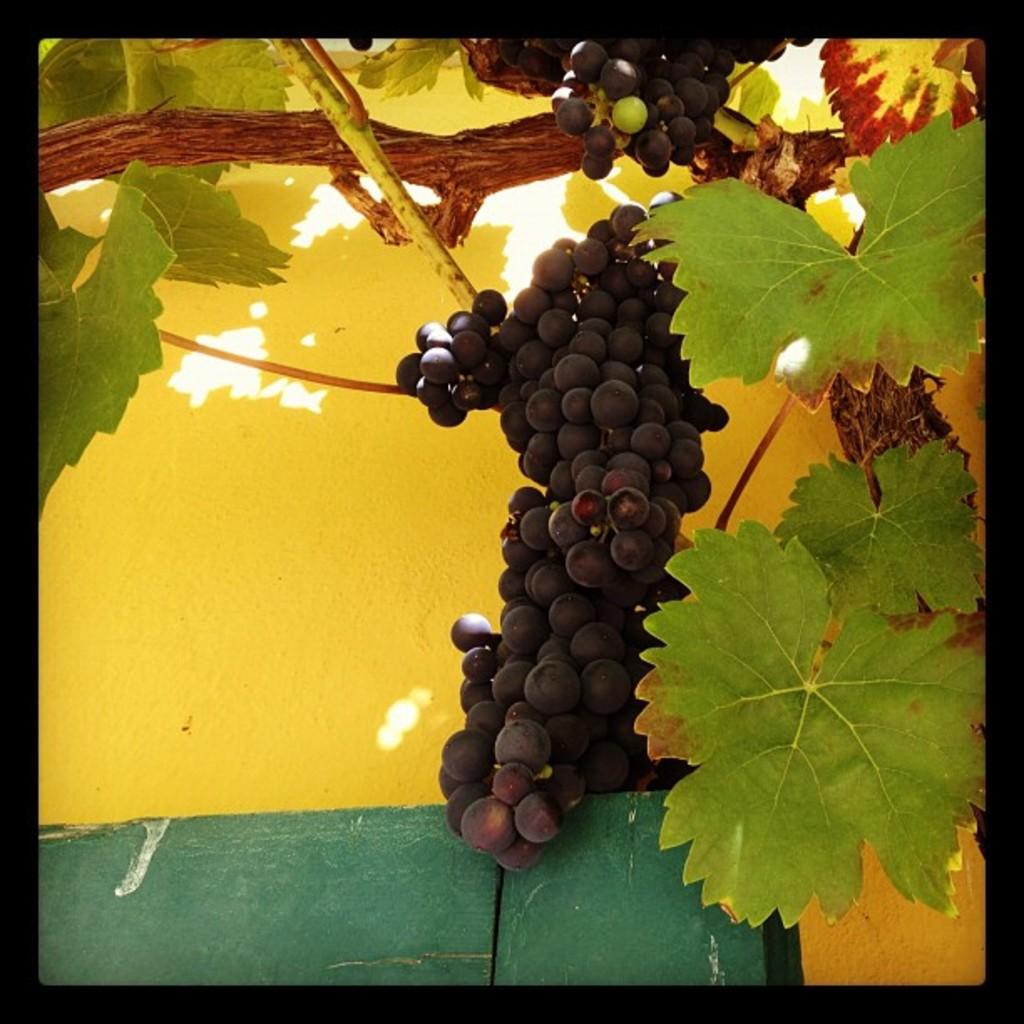What type of tree is in the image? There is a grape tree in the image. Are there any grapes on the tree? Yes, there are grapes on the tree. What color is the wall visible in the background of the image? The wall in the background of the image is yellow. What type of adjustment is being made to the throne in the image? There is no throne present in the image; it features a grape tree with grapes and a yellow wall in the background. 